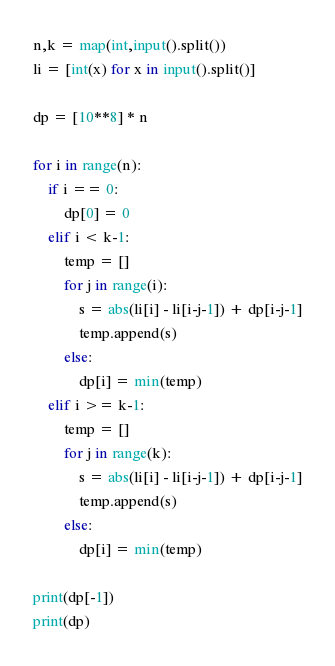Convert code to text. <code><loc_0><loc_0><loc_500><loc_500><_Python_>
n,k = map(int,input().split())
li = [int(x) for x in input().split()]

dp = [10**8] * n

for i in range(n):
    if i == 0:
        dp[0] = 0
    elif i < k-1:
        temp = []
        for j in range(i):
            s = abs(li[i] - li[i-j-1]) + dp[i-j-1]
            temp.append(s)
        else:
            dp[i] = min(temp)
    elif i >= k-1:
        temp = []
        for j in range(k):
            s = abs(li[i] - li[i-j-1]) + dp[i-j-1]
            temp.append(s)
        else:
            dp[i] = min(temp)
            
print(dp[-1])
print(dp)</code> 